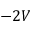Convert formula to latex. <formula><loc_0><loc_0><loc_500><loc_500>- 2 V</formula> 